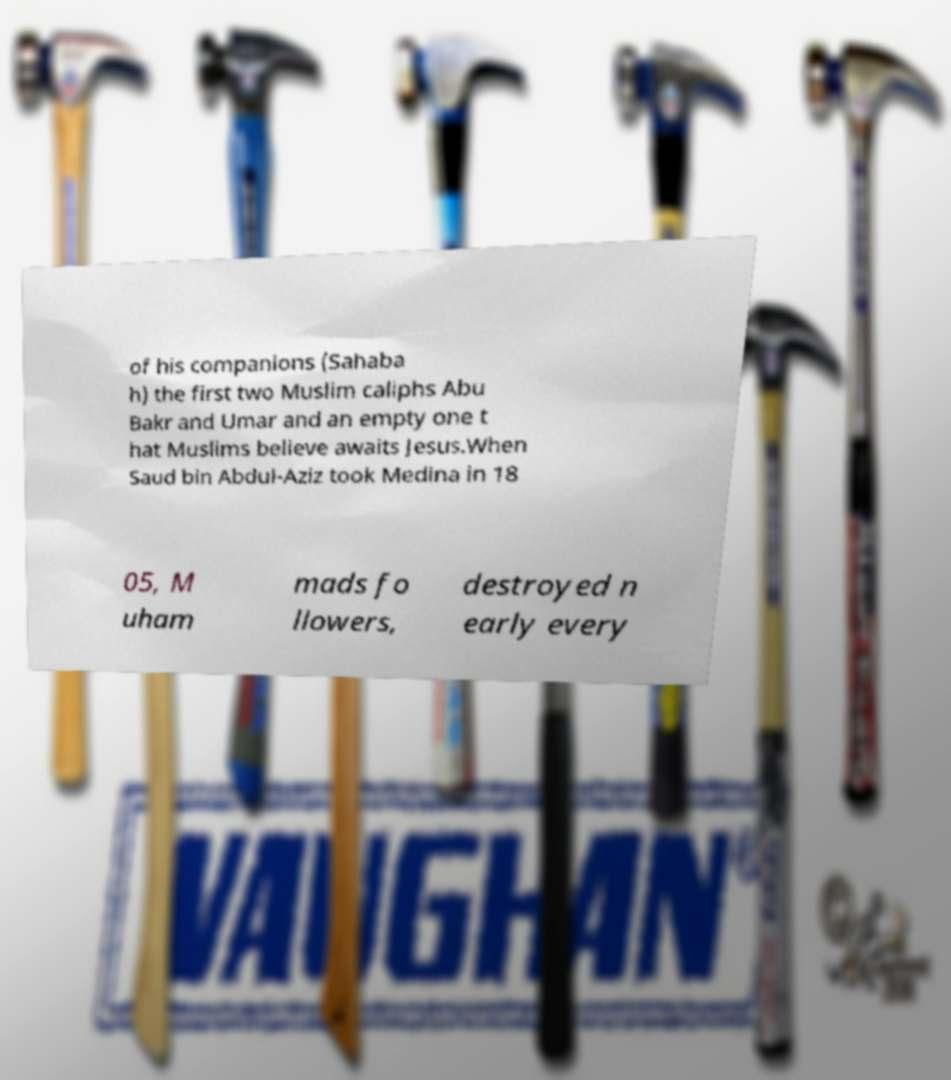Could you assist in decoding the text presented in this image and type it out clearly? of his companions (Sahaba h) the first two Muslim caliphs Abu Bakr and Umar and an empty one t hat Muslims believe awaits Jesus.When Saud bin Abdul-Aziz took Medina in 18 05, M uham mads fo llowers, destroyed n early every 